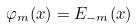<formula> <loc_0><loc_0><loc_500><loc_500>\varphi _ { m } ( x ) = E _ { - m } ( x )</formula> 